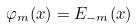<formula> <loc_0><loc_0><loc_500><loc_500>\varphi _ { m } ( x ) = E _ { - m } ( x )</formula> 